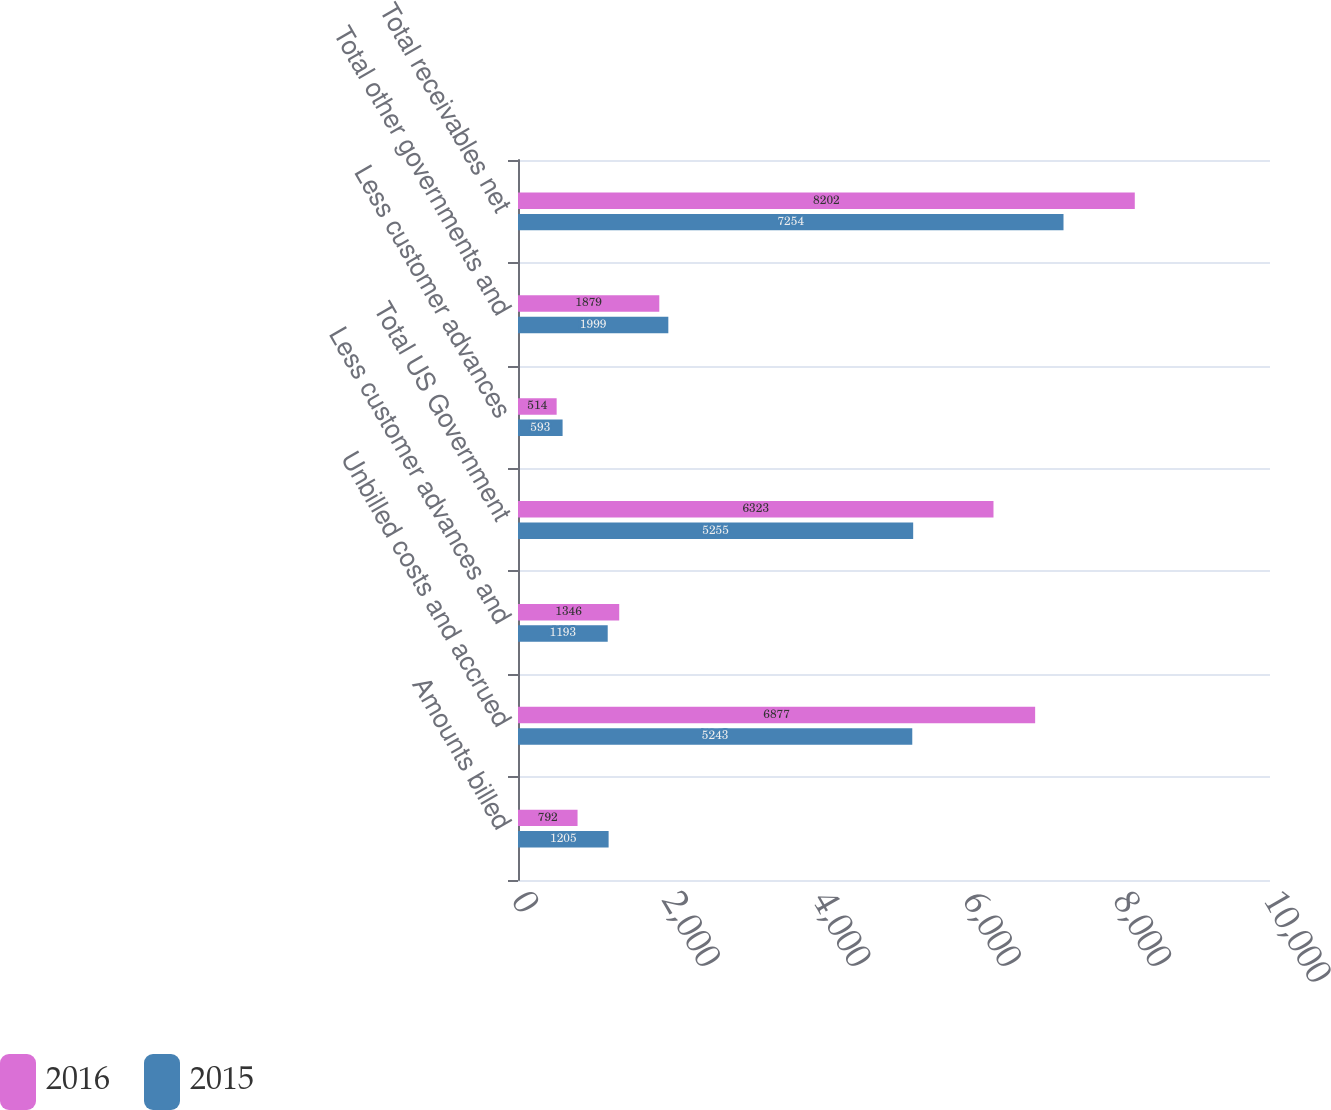Convert chart. <chart><loc_0><loc_0><loc_500><loc_500><stacked_bar_chart><ecel><fcel>Amounts billed<fcel>Unbilled costs and accrued<fcel>Less customer advances and<fcel>Total US Government<fcel>Less customer advances<fcel>Total other governments and<fcel>Total receivables net<nl><fcel>2016<fcel>792<fcel>6877<fcel>1346<fcel>6323<fcel>514<fcel>1879<fcel>8202<nl><fcel>2015<fcel>1205<fcel>5243<fcel>1193<fcel>5255<fcel>593<fcel>1999<fcel>7254<nl></chart> 